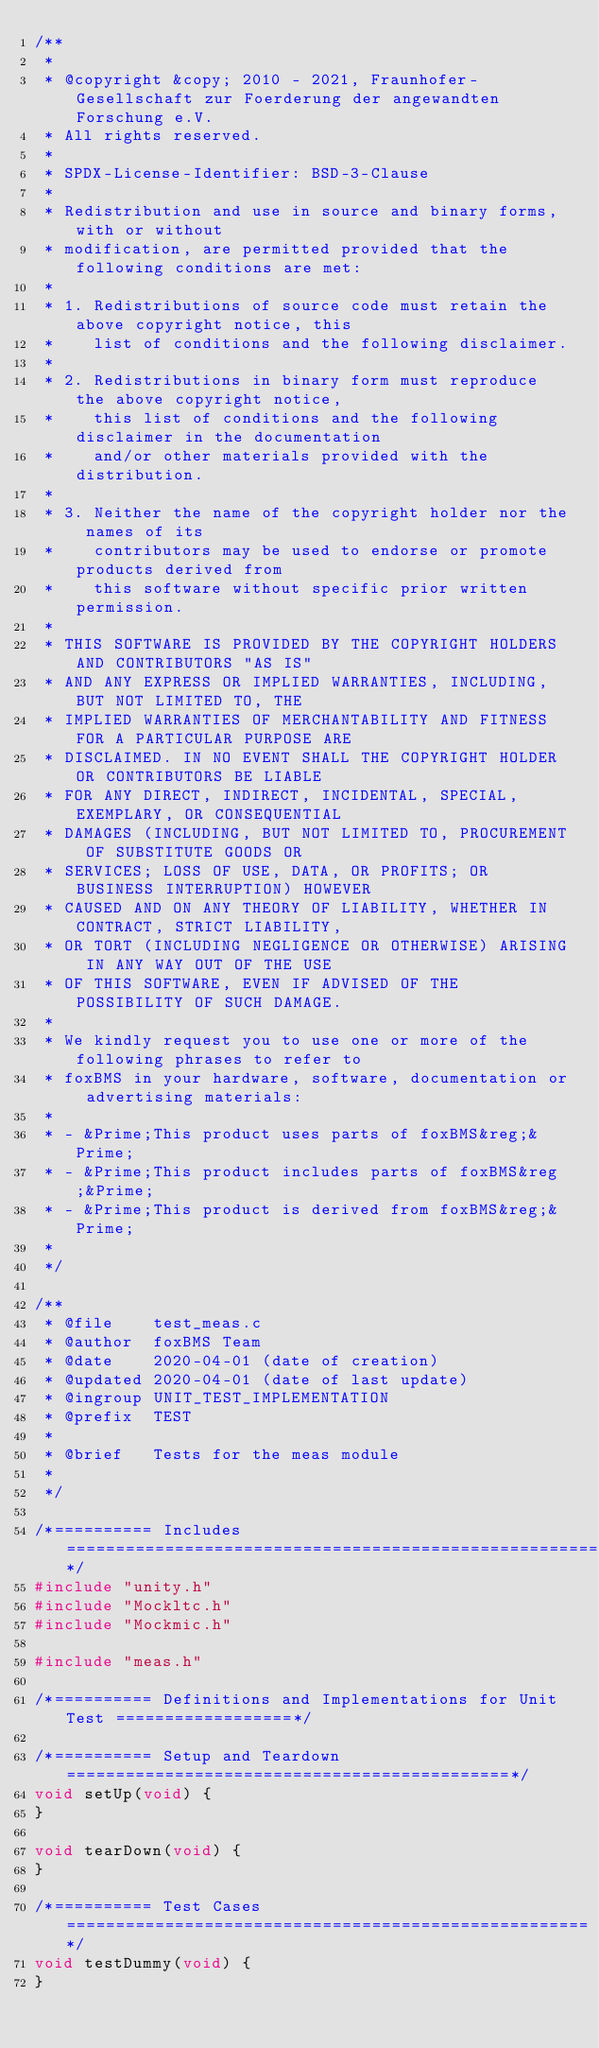Convert code to text. <code><loc_0><loc_0><loc_500><loc_500><_C_>/**
 *
 * @copyright &copy; 2010 - 2021, Fraunhofer-Gesellschaft zur Foerderung der angewandten Forschung e.V.
 * All rights reserved.
 *
 * SPDX-License-Identifier: BSD-3-Clause
 *
 * Redistribution and use in source and binary forms, with or without
 * modification, are permitted provided that the following conditions are met:
 *
 * 1. Redistributions of source code must retain the above copyright notice, this
 *    list of conditions and the following disclaimer.
 *
 * 2. Redistributions in binary form must reproduce the above copyright notice,
 *    this list of conditions and the following disclaimer in the documentation
 *    and/or other materials provided with the distribution.
 *
 * 3. Neither the name of the copyright holder nor the names of its
 *    contributors may be used to endorse or promote products derived from
 *    this software without specific prior written permission.
 *
 * THIS SOFTWARE IS PROVIDED BY THE COPYRIGHT HOLDERS AND CONTRIBUTORS "AS IS"
 * AND ANY EXPRESS OR IMPLIED WARRANTIES, INCLUDING, BUT NOT LIMITED TO, THE
 * IMPLIED WARRANTIES OF MERCHANTABILITY AND FITNESS FOR A PARTICULAR PURPOSE ARE
 * DISCLAIMED. IN NO EVENT SHALL THE COPYRIGHT HOLDER OR CONTRIBUTORS BE LIABLE
 * FOR ANY DIRECT, INDIRECT, INCIDENTAL, SPECIAL, EXEMPLARY, OR CONSEQUENTIAL
 * DAMAGES (INCLUDING, BUT NOT LIMITED TO, PROCUREMENT OF SUBSTITUTE GOODS OR
 * SERVICES; LOSS OF USE, DATA, OR PROFITS; OR BUSINESS INTERRUPTION) HOWEVER
 * CAUSED AND ON ANY THEORY OF LIABILITY, WHETHER IN CONTRACT, STRICT LIABILITY,
 * OR TORT (INCLUDING NEGLIGENCE OR OTHERWISE) ARISING IN ANY WAY OUT OF THE USE
 * OF THIS SOFTWARE, EVEN IF ADVISED OF THE POSSIBILITY OF SUCH DAMAGE.
 *
 * We kindly request you to use one or more of the following phrases to refer to
 * foxBMS in your hardware, software, documentation or advertising materials:
 *
 * - &Prime;This product uses parts of foxBMS&reg;&Prime;
 * - &Prime;This product includes parts of foxBMS&reg;&Prime;
 * - &Prime;This product is derived from foxBMS&reg;&Prime;
 *
 */

/**
 * @file    test_meas.c
 * @author  foxBMS Team
 * @date    2020-04-01 (date of creation)
 * @updated 2020-04-01 (date of last update)
 * @ingroup UNIT_TEST_IMPLEMENTATION
 * @prefix  TEST
 *
 * @brief   Tests for the meas module
 *
 */

/*========== Includes =======================================================*/
#include "unity.h"
#include "Mockltc.h"
#include "Mockmic.h"

#include "meas.h"

/*========== Definitions and Implementations for Unit Test ==================*/

/*========== Setup and Teardown =============================================*/
void setUp(void) {
}

void tearDown(void) {
}

/*========== Test Cases =====================================================*/
void testDummy(void) {
}
</code> 